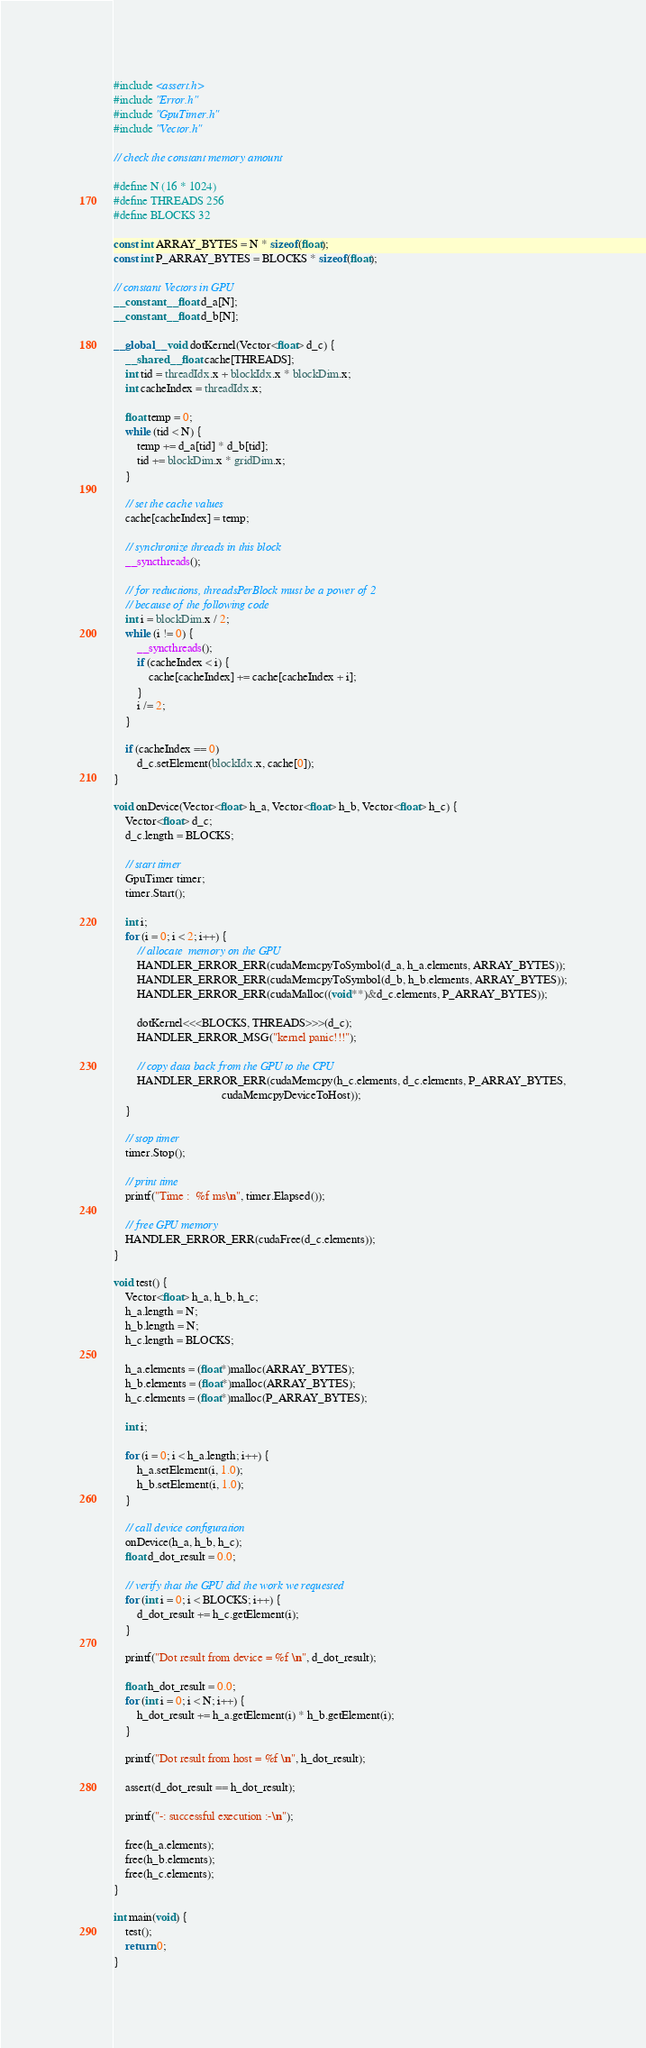<code> <loc_0><loc_0><loc_500><loc_500><_Cuda_>#include <assert.h>
#include "Error.h"
#include "GpuTimer.h"
#include "Vector.h"

// check the constant memory amount

#define N (16 * 1024)
#define THREADS 256
#define BLOCKS 32

const int ARRAY_BYTES = N * sizeof(float);
const int P_ARRAY_BYTES = BLOCKS * sizeof(float);

// constant Vectors in GPU
__constant__ float d_a[N];
__constant__ float d_b[N];

__global__ void dotKernel(Vector<float> d_c) {
    __shared__ float cache[THREADS];
    int tid = threadIdx.x + blockIdx.x * blockDim.x;
    int cacheIndex = threadIdx.x;

    float temp = 0;
    while (tid < N) {
        temp += d_a[tid] * d_b[tid];
        tid += blockDim.x * gridDim.x;
    }

    // set the cache values
    cache[cacheIndex] = temp;

    // synchronize threads in this block
    __syncthreads();

    // for reductions, threadsPerBlock must be a power of 2
    // because of the following code
    int i = blockDim.x / 2;
    while (i != 0) {
        __syncthreads();
        if (cacheIndex < i) {
            cache[cacheIndex] += cache[cacheIndex + i];
        }
        i /= 2;
    }

    if (cacheIndex == 0)
        d_c.setElement(blockIdx.x, cache[0]);
}

void onDevice(Vector<float> h_a, Vector<float> h_b, Vector<float> h_c) {
    Vector<float> d_c;
    d_c.length = BLOCKS;

    // start timer
    GpuTimer timer;
    timer.Start();

    int i;
    for (i = 0; i < 2; i++) {
        // allocate  memory on the GPU
        HANDLER_ERROR_ERR(cudaMemcpyToSymbol(d_a, h_a.elements, ARRAY_BYTES));
        HANDLER_ERROR_ERR(cudaMemcpyToSymbol(d_b, h_b.elements, ARRAY_BYTES));
        HANDLER_ERROR_ERR(cudaMalloc((void**)&d_c.elements, P_ARRAY_BYTES));

        dotKernel<<<BLOCKS, THREADS>>>(d_c);
        HANDLER_ERROR_MSG("kernel panic!!!");

        // copy data back from the GPU to the CPU
        HANDLER_ERROR_ERR(cudaMemcpy(h_c.elements, d_c.elements, P_ARRAY_BYTES,
                                     cudaMemcpyDeviceToHost));
    }

    // stop timer
    timer.Stop();

    // print time
    printf("Time :  %f ms\n", timer.Elapsed());

    // free GPU memory
    HANDLER_ERROR_ERR(cudaFree(d_c.elements));
}

void test() {
    Vector<float> h_a, h_b, h_c;
    h_a.length = N;
    h_b.length = N;
    h_c.length = BLOCKS;

    h_a.elements = (float*)malloc(ARRAY_BYTES);
    h_b.elements = (float*)malloc(ARRAY_BYTES);
    h_c.elements = (float*)malloc(P_ARRAY_BYTES);

    int i;

    for (i = 0; i < h_a.length; i++) {
        h_a.setElement(i, 1.0);
        h_b.setElement(i, 1.0);
    }

    // call device configuration
    onDevice(h_a, h_b, h_c);
    float d_dot_result = 0.0;

    // verify that the GPU did the work we requested
    for (int i = 0; i < BLOCKS; i++) {
        d_dot_result += h_c.getElement(i);
    }

    printf("Dot result from device = %f \n", d_dot_result);

    float h_dot_result = 0.0;
    for (int i = 0; i < N; i++) {
        h_dot_result += h_a.getElement(i) * h_b.getElement(i);
    }

    printf("Dot result from host = %f \n", h_dot_result);

    assert(d_dot_result == h_dot_result);

    printf("-: successful execution :-\n");

    free(h_a.elements);
    free(h_b.elements);
    free(h_c.elements);
}

int main(void) {
    test();
    return 0;
}
</code> 